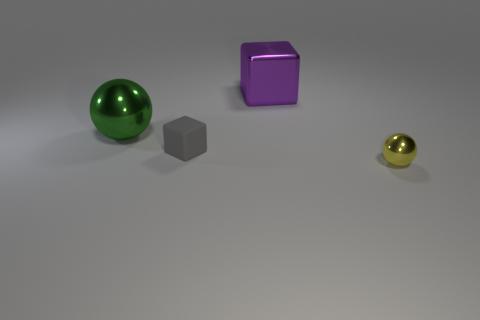Add 3 tiny brown shiny cubes. How many objects exist? 7 Add 1 tiny yellow metal things. How many tiny yellow metal things are left? 2 Add 4 green metallic spheres. How many green metallic spheres exist? 5 Subtract 0 yellow cylinders. How many objects are left? 4 Subtract all green metallic things. Subtract all tiny rubber things. How many objects are left? 2 